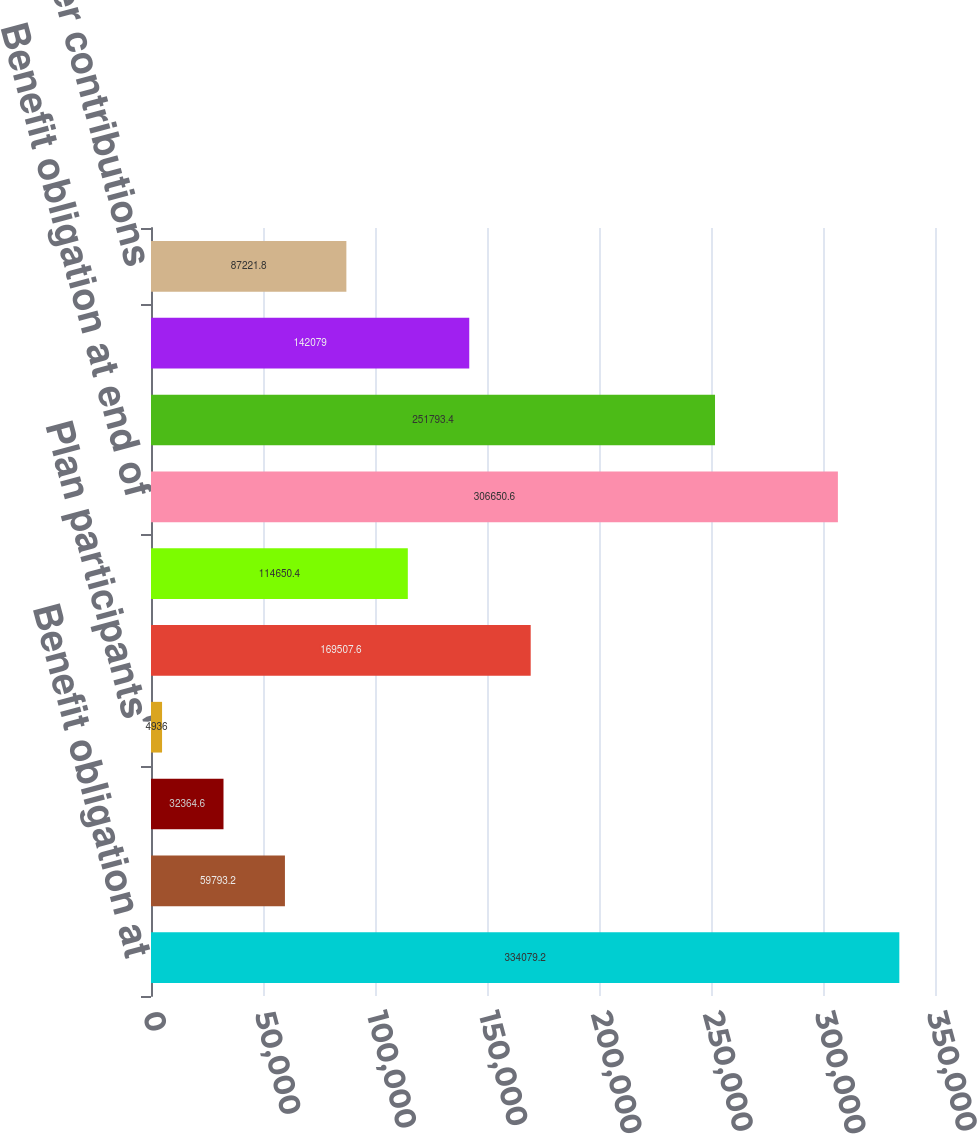Convert chart to OTSL. <chart><loc_0><loc_0><loc_500><loc_500><bar_chart><fcel>Benefit obligation at<fcel>Service cost<fcel>Interest cost<fcel>Plan participants'<fcel>Actuarial gain<fcel>Benefits paid<fcel>Benefit obligation at end of<fcel>Fair value of plan assets at<fcel>Actual return on plan assets<fcel>Employer contributions<nl><fcel>334079<fcel>59793.2<fcel>32364.6<fcel>4936<fcel>169508<fcel>114650<fcel>306651<fcel>251793<fcel>142079<fcel>87221.8<nl></chart> 